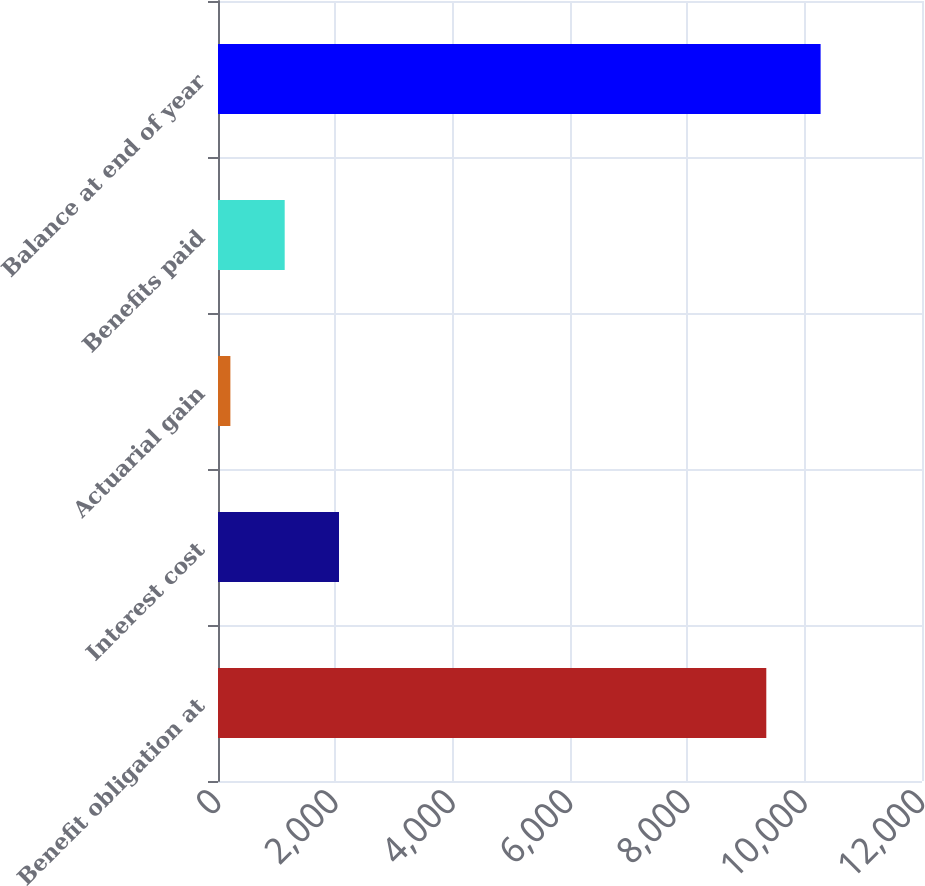Convert chart to OTSL. <chart><loc_0><loc_0><loc_500><loc_500><bar_chart><fcel>Benefit obligation at<fcel>Interest cost<fcel>Actuarial gain<fcel>Benefits paid<fcel>Balance at end of year<nl><fcel>9346<fcel>2062.6<fcel>211<fcel>1136.8<fcel>10271.8<nl></chart> 